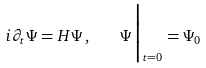Convert formula to latex. <formula><loc_0><loc_0><loc_500><loc_500>i \partial _ { t } \Psi = H \Psi \, , \quad \Psi \Big | _ { t = 0 } = \Psi _ { 0 }</formula> 